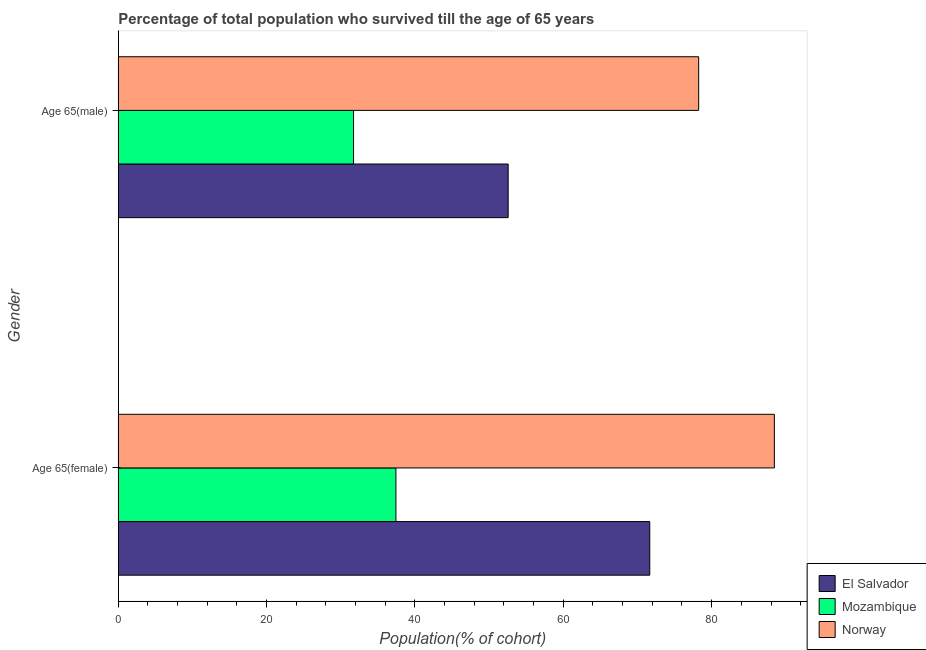How many different coloured bars are there?
Offer a very short reply. 3. How many groups of bars are there?
Provide a succinct answer. 2. Are the number of bars per tick equal to the number of legend labels?
Provide a short and direct response. Yes. Are the number of bars on each tick of the Y-axis equal?
Offer a terse response. Yes. How many bars are there on the 1st tick from the bottom?
Ensure brevity in your answer.  3. What is the label of the 2nd group of bars from the top?
Offer a very short reply. Age 65(female). What is the percentage of female population who survived till age of 65 in Norway?
Your response must be concise. 88.45. Across all countries, what is the maximum percentage of male population who survived till age of 65?
Make the answer very short. 78.25. Across all countries, what is the minimum percentage of female population who survived till age of 65?
Keep it short and to the point. 37.43. In which country was the percentage of female population who survived till age of 65 maximum?
Your answer should be compact. Norway. In which country was the percentage of male population who survived till age of 65 minimum?
Ensure brevity in your answer.  Mozambique. What is the total percentage of male population who survived till age of 65 in the graph?
Give a very brief answer. 162.53. What is the difference between the percentage of male population who survived till age of 65 in Mozambique and that in Norway?
Your response must be concise. -46.53. What is the difference between the percentage of female population who survived till age of 65 in Norway and the percentage of male population who survived till age of 65 in Mozambique?
Offer a very short reply. 56.73. What is the average percentage of female population who survived till age of 65 per country?
Give a very brief answer. 65.85. What is the difference between the percentage of male population who survived till age of 65 and percentage of female population who survived till age of 65 in Norway?
Offer a very short reply. -10.2. In how many countries, is the percentage of female population who survived till age of 65 greater than 40 %?
Your response must be concise. 2. What is the ratio of the percentage of male population who survived till age of 65 in El Salvador to that in Norway?
Your answer should be compact. 0.67. Is the percentage of male population who survived till age of 65 in El Salvador less than that in Norway?
Give a very brief answer. Yes. What does the 3rd bar from the top in Age 65(male) represents?
Give a very brief answer. El Salvador. What does the 1st bar from the bottom in Age 65(female) represents?
Ensure brevity in your answer.  El Salvador. How many countries are there in the graph?
Your answer should be very brief. 3. What is the difference between two consecutive major ticks on the X-axis?
Ensure brevity in your answer.  20. Does the graph contain grids?
Make the answer very short. No. What is the title of the graph?
Offer a terse response. Percentage of total population who survived till the age of 65 years. Does "Tajikistan" appear as one of the legend labels in the graph?
Offer a very short reply. No. What is the label or title of the X-axis?
Provide a succinct answer. Population(% of cohort). What is the label or title of the Y-axis?
Give a very brief answer. Gender. What is the Population(% of cohort) of El Salvador in Age 65(female)?
Offer a very short reply. 71.65. What is the Population(% of cohort) of Mozambique in Age 65(female)?
Offer a very short reply. 37.43. What is the Population(% of cohort) of Norway in Age 65(female)?
Offer a terse response. 88.45. What is the Population(% of cohort) in El Salvador in Age 65(male)?
Provide a short and direct response. 52.57. What is the Population(% of cohort) in Mozambique in Age 65(male)?
Provide a short and direct response. 31.72. What is the Population(% of cohort) in Norway in Age 65(male)?
Keep it short and to the point. 78.25. Across all Gender, what is the maximum Population(% of cohort) of El Salvador?
Provide a short and direct response. 71.65. Across all Gender, what is the maximum Population(% of cohort) of Mozambique?
Ensure brevity in your answer.  37.43. Across all Gender, what is the maximum Population(% of cohort) of Norway?
Keep it short and to the point. 88.45. Across all Gender, what is the minimum Population(% of cohort) in El Salvador?
Ensure brevity in your answer.  52.57. Across all Gender, what is the minimum Population(% of cohort) in Mozambique?
Keep it short and to the point. 31.72. Across all Gender, what is the minimum Population(% of cohort) in Norway?
Provide a short and direct response. 78.25. What is the total Population(% of cohort) of El Salvador in the graph?
Your answer should be very brief. 124.22. What is the total Population(% of cohort) in Mozambique in the graph?
Offer a terse response. 69.15. What is the total Population(% of cohort) in Norway in the graph?
Offer a terse response. 166.7. What is the difference between the Population(% of cohort) of El Salvador in Age 65(female) and that in Age 65(male)?
Give a very brief answer. 19.09. What is the difference between the Population(% of cohort) in Mozambique in Age 65(female) and that in Age 65(male)?
Make the answer very short. 5.71. What is the difference between the Population(% of cohort) in Norway in Age 65(female) and that in Age 65(male)?
Keep it short and to the point. 10.2. What is the difference between the Population(% of cohort) in El Salvador in Age 65(female) and the Population(% of cohort) in Mozambique in Age 65(male)?
Make the answer very short. 39.93. What is the difference between the Population(% of cohort) of El Salvador in Age 65(female) and the Population(% of cohort) of Norway in Age 65(male)?
Make the answer very short. -6.59. What is the difference between the Population(% of cohort) in Mozambique in Age 65(female) and the Population(% of cohort) in Norway in Age 65(male)?
Your answer should be very brief. -40.82. What is the average Population(% of cohort) in El Salvador per Gender?
Provide a short and direct response. 62.11. What is the average Population(% of cohort) in Mozambique per Gender?
Ensure brevity in your answer.  34.58. What is the average Population(% of cohort) in Norway per Gender?
Your answer should be compact. 83.35. What is the difference between the Population(% of cohort) of El Salvador and Population(% of cohort) of Mozambique in Age 65(female)?
Provide a succinct answer. 34.22. What is the difference between the Population(% of cohort) in El Salvador and Population(% of cohort) in Norway in Age 65(female)?
Provide a short and direct response. -16.8. What is the difference between the Population(% of cohort) of Mozambique and Population(% of cohort) of Norway in Age 65(female)?
Offer a terse response. -51.02. What is the difference between the Population(% of cohort) in El Salvador and Population(% of cohort) in Mozambique in Age 65(male)?
Give a very brief answer. 20.84. What is the difference between the Population(% of cohort) of El Salvador and Population(% of cohort) of Norway in Age 65(male)?
Provide a short and direct response. -25.68. What is the difference between the Population(% of cohort) in Mozambique and Population(% of cohort) in Norway in Age 65(male)?
Your answer should be very brief. -46.53. What is the ratio of the Population(% of cohort) in El Salvador in Age 65(female) to that in Age 65(male)?
Provide a succinct answer. 1.36. What is the ratio of the Population(% of cohort) in Mozambique in Age 65(female) to that in Age 65(male)?
Provide a short and direct response. 1.18. What is the ratio of the Population(% of cohort) of Norway in Age 65(female) to that in Age 65(male)?
Your answer should be compact. 1.13. What is the difference between the highest and the second highest Population(% of cohort) of El Salvador?
Your answer should be very brief. 19.09. What is the difference between the highest and the second highest Population(% of cohort) in Mozambique?
Your response must be concise. 5.71. What is the difference between the highest and the second highest Population(% of cohort) in Norway?
Keep it short and to the point. 10.2. What is the difference between the highest and the lowest Population(% of cohort) of El Salvador?
Provide a succinct answer. 19.09. What is the difference between the highest and the lowest Population(% of cohort) of Mozambique?
Keep it short and to the point. 5.71. What is the difference between the highest and the lowest Population(% of cohort) in Norway?
Provide a short and direct response. 10.2. 